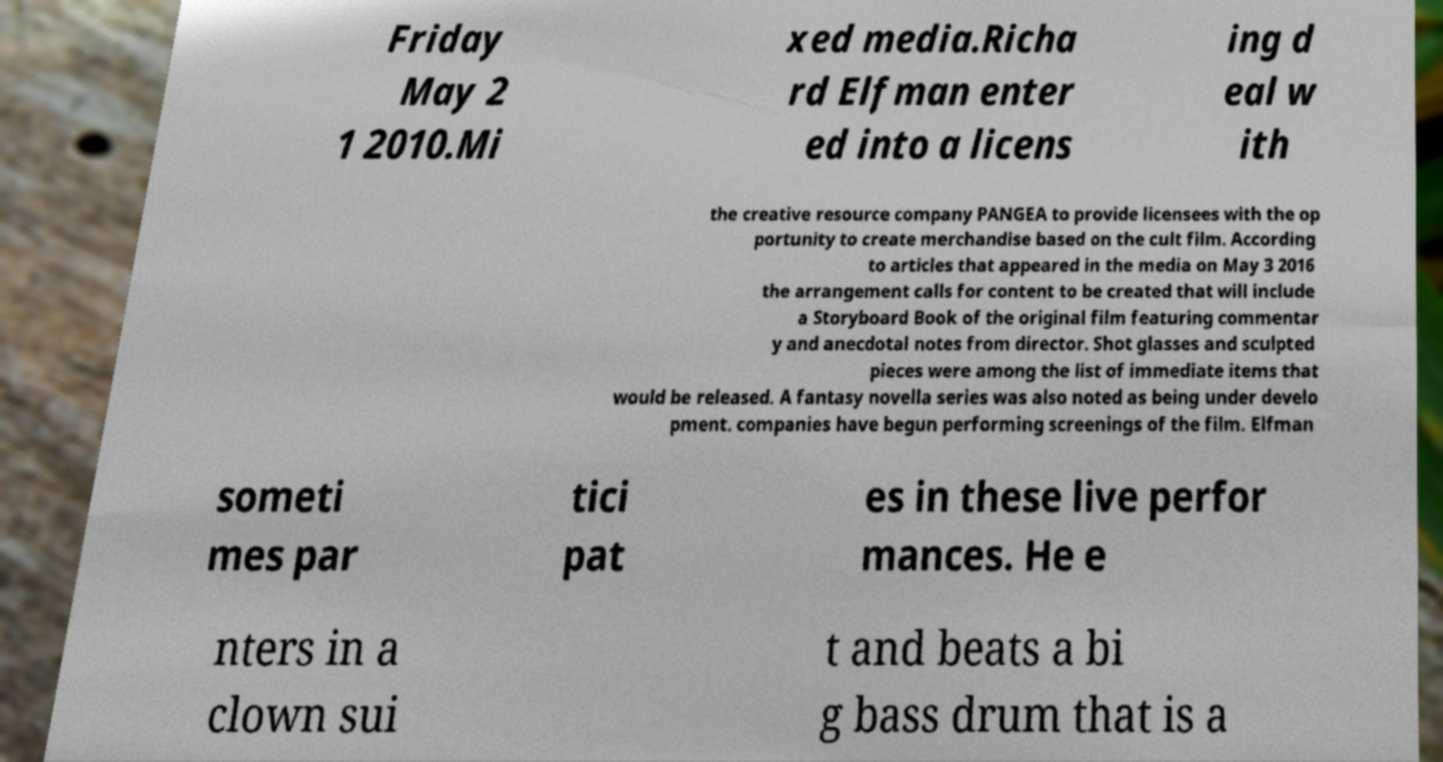Could you assist in decoding the text presented in this image and type it out clearly? Friday May 2 1 2010.Mi xed media.Richa rd Elfman enter ed into a licens ing d eal w ith the creative resource company PANGEA to provide licensees with the op portunity to create merchandise based on the cult film. According to articles that appeared in the media on May 3 2016 the arrangement calls for content to be created that will include a Storyboard Book of the original film featuring commentar y and anecdotal notes from director. Shot glasses and sculpted pieces were among the list of immediate items that would be released. A fantasy novella series was also noted as being under develo pment. companies have begun performing screenings of the film. Elfman someti mes par tici pat es in these live perfor mances. He e nters in a clown sui t and beats a bi g bass drum that is a 